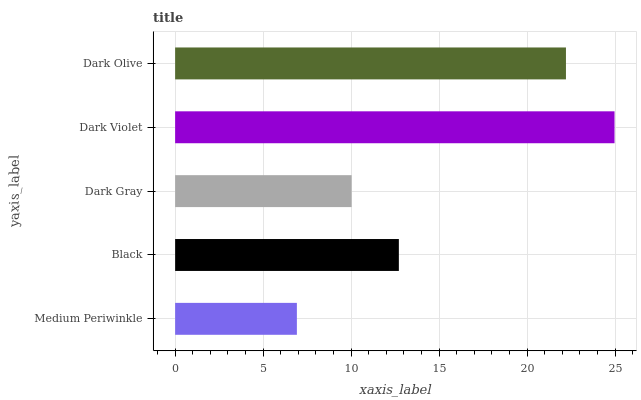Is Medium Periwinkle the minimum?
Answer yes or no. Yes. Is Dark Violet the maximum?
Answer yes or no. Yes. Is Black the minimum?
Answer yes or no. No. Is Black the maximum?
Answer yes or no. No. Is Black greater than Medium Periwinkle?
Answer yes or no. Yes. Is Medium Periwinkle less than Black?
Answer yes or no. Yes. Is Medium Periwinkle greater than Black?
Answer yes or no. No. Is Black less than Medium Periwinkle?
Answer yes or no. No. Is Black the high median?
Answer yes or no. Yes. Is Black the low median?
Answer yes or no. Yes. Is Dark Olive the high median?
Answer yes or no. No. Is Dark Violet the low median?
Answer yes or no. No. 